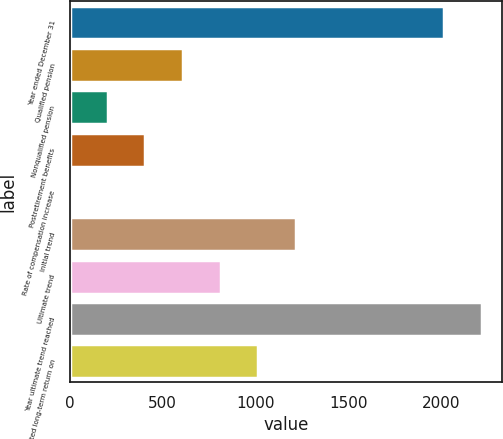Convert chart to OTSL. <chart><loc_0><loc_0><loc_500><loc_500><bar_chart><fcel>Year ended December 31<fcel>Qualified pension<fcel>Nonqualified pension<fcel>Postretirement benefits<fcel>Rate of compensation increase<fcel>Initial trend<fcel>Ultimate trend<fcel>Year ultimate trend reached<fcel>Expected long-term return on<nl><fcel>2016<fcel>609.95<fcel>205.65<fcel>407.8<fcel>3.5<fcel>1216.4<fcel>812.1<fcel>2218.15<fcel>1014.25<nl></chart> 